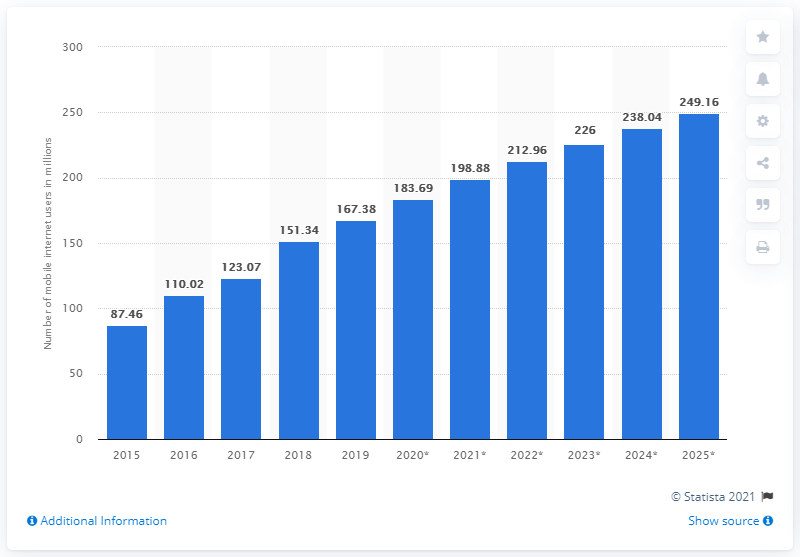Outline some significant characteristics in this image. In 2019, an estimated 167.38 million individuals in Indonesia accessed the internet through their mobile devices. By 2025, it is projected that there will be approximately 249.16 million mobile internet users in Indonesia. 